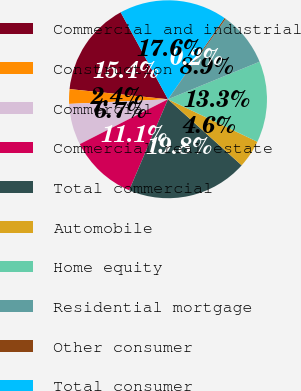<chart> <loc_0><loc_0><loc_500><loc_500><pie_chart><fcel>Commercial and industrial<fcel>Construction<fcel>Commercial<fcel>Commercial real estate<fcel>Total commercial<fcel>Automobile<fcel>Home equity<fcel>Residential mortgage<fcel>Other consumer<fcel>Total consumer<nl><fcel>15.43%<fcel>2.39%<fcel>6.74%<fcel>11.09%<fcel>19.78%<fcel>4.57%<fcel>13.26%<fcel>8.91%<fcel>0.22%<fcel>17.61%<nl></chart> 